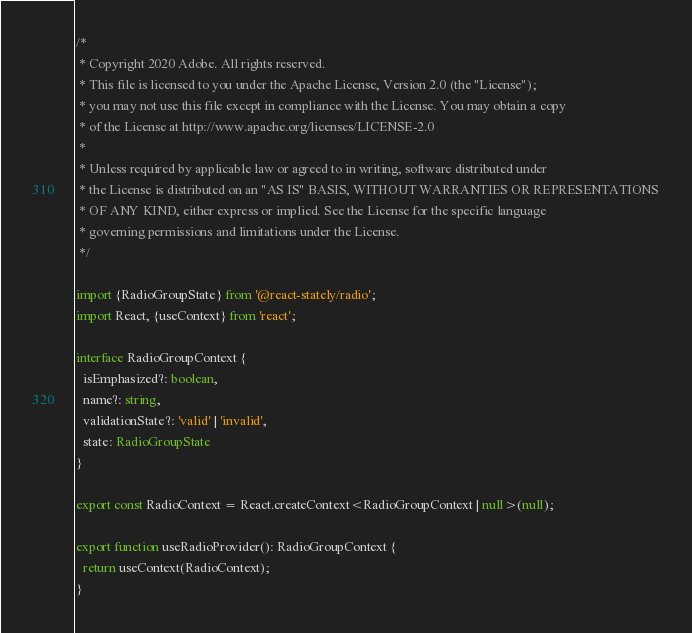Convert code to text. <code><loc_0><loc_0><loc_500><loc_500><_TypeScript_>/*
 * Copyright 2020 Adobe. All rights reserved.
 * This file is licensed to you under the Apache License, Version 2.0 (the "License");
 * you may not use this file except in compliance with the License. You may obtain a copy
 * of the License at http://www.apache.org/licenses/LICENSE-2.0
 *
 * Unless required by applicable law or agreed to in writing, software distributed under
 * the License is distributed on an "AS IS" BASIS, WITHOUT WARRANTIES OR REPRESENTATIONS
 * OF ANY KIND, either express or implied. See the License for the specific language
 * governing permissions and limitations under the License.
 */

import {RadioGroupState} from '@react-stately/radio';
import React, {useContext} from 'react';

interface RadioGroupContext {
  isEmphasized?: boolean,
  name?: string,
  validationState?: 'valid' | 'invalid',
  state: RadioGroupState
}

export const RadioContext = React.createContext<RadioGroupContext | null>(null);

export function useRadioProvider(): RadioGroupContext {
  return useContext(RadioContext);
}
</code> 